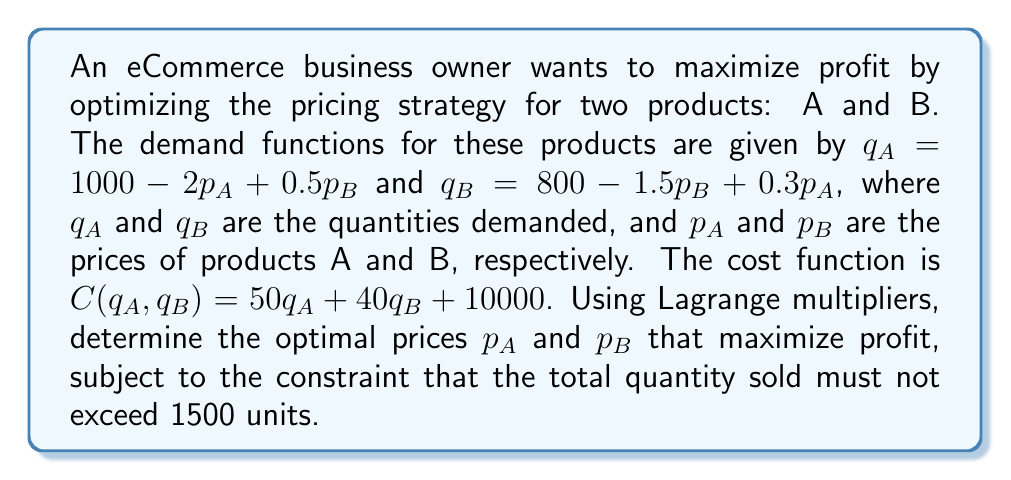Can you solve this math problem? To solve this problem using Lagrange multipliers, we follow these steps:

1. Define the profit function:
   Profit = Revenue - Cost
   $\Pi = p_A q_A + p_B q_B - C(q_A, q_B)$
   
2. Substitute the demand functions and cost function:
   $\Pi = p_A(1000 - 2p_A + 0.5p_B) + p_B(800 - 1.5p_B + 0.3p_A) - [50(1000 - 2p_A + 0.5p_B) + 40(800 - 1.5p_B + 0.3p_A) + 10000]$

3. Define the constraint function:
   $g(p_A, p_B) = (1000 - 2p_A + 0.5p_B) + (800 - 1.5p_B + 0.3p_A) - 1500 = 0$

4. Form the Lagrangian function:
   $L(p_A, p_B, \lambda) = \Pi(p_A, p_B) - \lambda g(p_A, p_B)$

5. Calculate partial derivatives and set them to zero:
   $\frac{\partial L}{\partial p_A} = 1000 - 4p_A + 0.5p_B + 0.3p_B - 0.3\lambda + 100 = 0$
   $\frac{\partial L}{\partial p_B} = 800 - 3p_B + 0.3p_A + 0.5p_A - 0.5\lambda + 60 = 0$
   $\frac{\partial L}{\partial \lambda} = -300 + 1.7p_A + p_B = 0$

6. Solve the system of equations:
   From the third equation: $p_B = 300 - 1.7p_A$
   Substitute this into the first two equations and solve for $p_A$:
   $1100 - 4p_A + 0.8(300 - 1.7p_A) - 0.3\lambda = 0$
   $860 - 3(300 - 1.7p_A) + 0.8p_A - 0.5\lambda = 0$

   Solving these equations simultaneously yields:
   $p_A \approx 372.73$ and $p_B \approx 366.36$

7. Round the prices to the nearest cent for practical application.
Answer: $p_A = \$372.73, p_B = \$366.36$ 